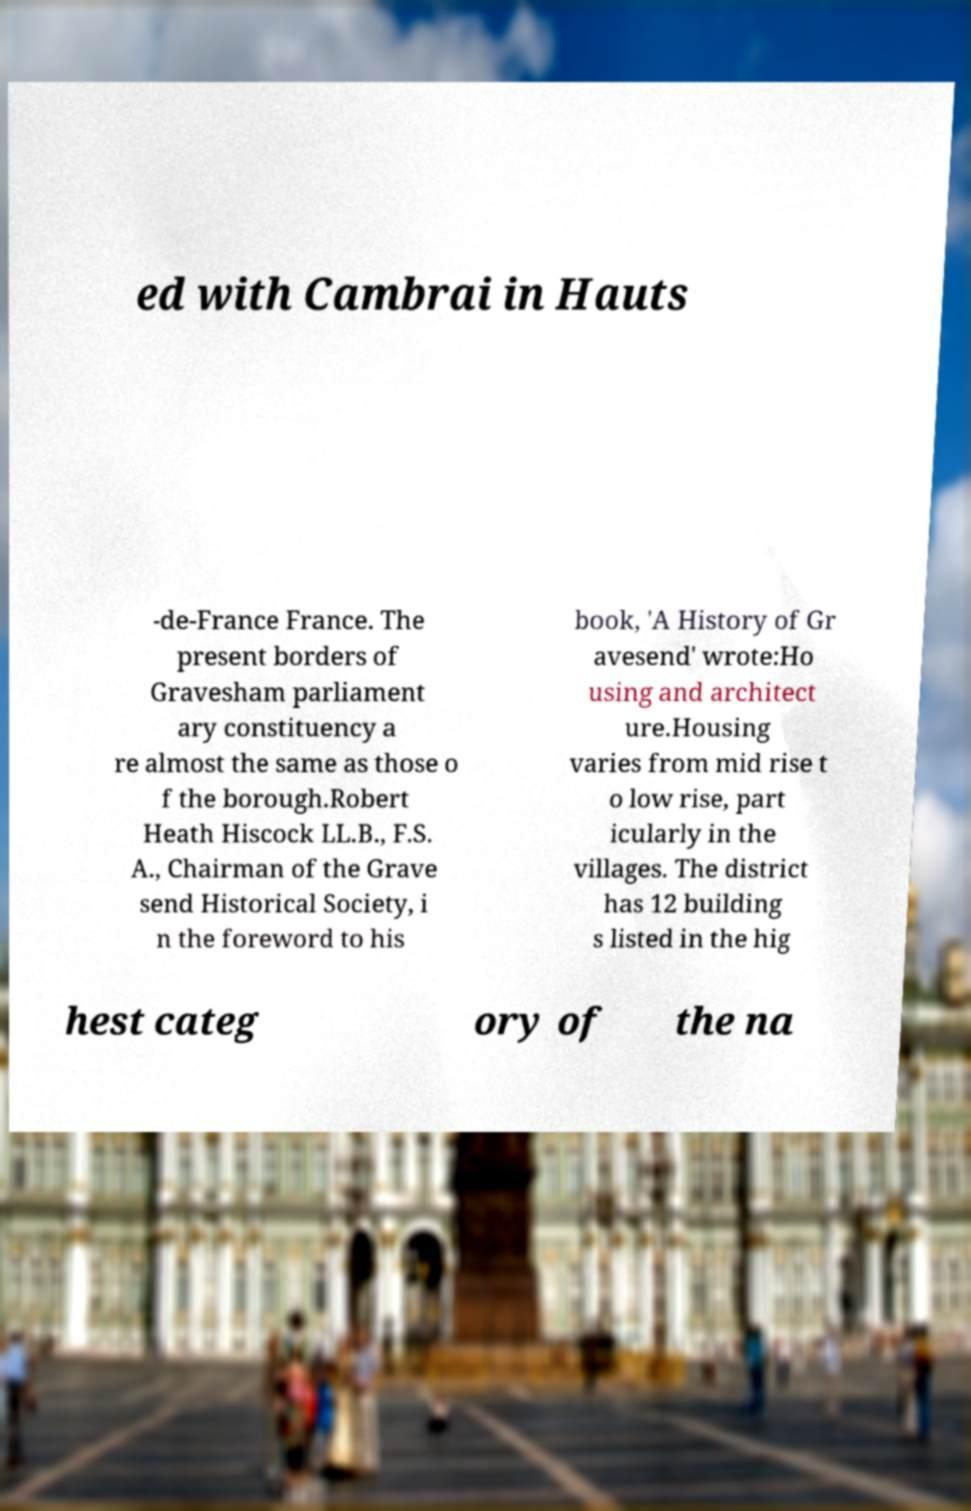Could you extract and type out the text from this image? ed with Cambrai in Hauts -de-France France. The present borders of Gravesham parliament ary constituency a re almost the same as those o f the borough.Robert Heath Hiscock LL.B., F.S. A., Chairman of the Grave send Historical Society, i n the foreword to his book, 'A History of Gr avesend' wrote:Ho using and architect ure.Housing varies from mid rise t o low rise, part icularly in the villages. The district has 12 building s listed in the hig hest categ ory of the na 